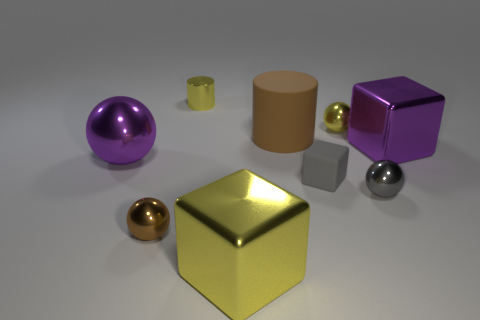Subtract 2 spheres. How many spheres are left? 2 Subtract all green spheres. Subtract all red blocks. How many spheres are left? 4 Add 1 tiny yellow spheres. How many objects exist? 10 Subtract all blocks. How many objects are left? 6 Add 3 big purple shiny things. How many big purple shiny things exist? 5 Subtract 0 purple cylinders. How many objects are left? 9 Subtract all large objects. Subtract all brown metallic things. How many objects are left? 4 Add 9 tiny blocks. How many tiny blocks are left? 10 